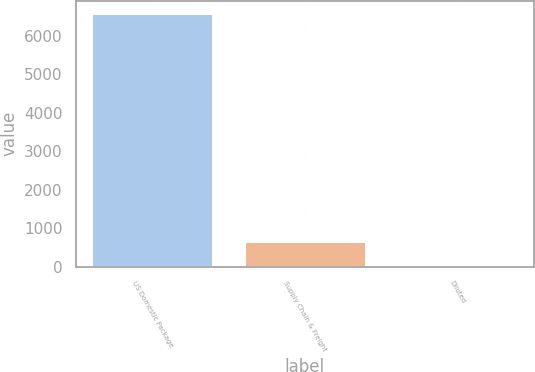<chart> <loc_0><loc_0><loc_500><loc_500><bar_chart><fcel>US Domestic Package<fcel>Supply Chain & Freight<fcel>Diluted<nl><fcel>6581<fcel>658.8<fcel>0.78<nl></chart> 